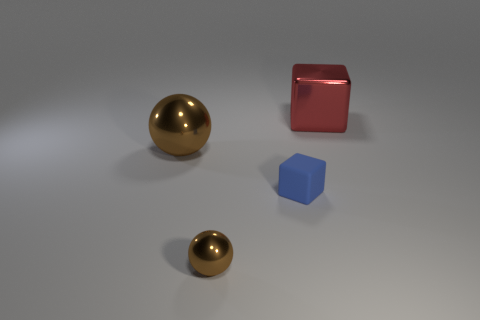Does the brown thing behind the tiny brown metallic sphere have the same material as the tiny block?
Keep it short and to the point. No. There is a metal ball that is in front of the brown shiny sphere to the left of the brown shiny sphere in front of the large brown metal object; what size is it?
Provide a succinct answer. Small. What number of other objects are there of the same color as the matte object?
Keep it short and to the point. 0. There is a metallic object that is the same size as the matte thing; what shape is it?
Make the answer very short. Sphere. There is a metal object in front of the tiny matte block; what size is it?
Offer a very short reply. Small. There is a tiny object left of the rubber object; is it the same color as the big object that is on the left side of the big block?
Your answer should be compact. Yes. There is a large object right of the brown shiny ball that is in front of the brown shiny sphere behind the rubber block; what is it made of?
Make the answer very short. Metal. Is there a purple rubber cylinder that has the same size as the metal cube?
Give a very brief answer. No. There is another object that is the same size as the red metal object; what is it made of?
Ensure brevity in your answer.  Metal. What is the shape of the large thing that is behind the big brown thing?
Keep it short and to the point. Cube. 